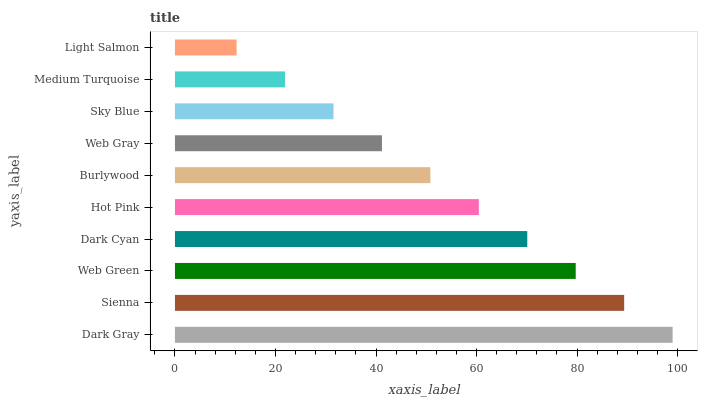Is Light Salmon the minimum?
Answer yes or no. Yes. Is Dark Gray the maximum?
Answer yes or no. Yes. Is Sienna the minimum?
Answer yes or no. No. Is Sienna the maximum?
Answer yes or no. No. Is Dark Gray greater than Sienna?
Answer yes or no. Yes. Is Sienna less than Dark Gray?
Answer yes or no. Yes. Is Sienna greater than Dark Gray?
Answer yes or no. No. Is Dark Gray less than Sienna?
Answer yes or no. No. Is Hot Pink the high median?
Answer yes or no. Yes. Is Burlywood the low median?
Answer yes or no. Yes. Is Sky Blue the high median?
Answer yes or no. No. Is Sienna the low median?
Answer yes or no. No. 